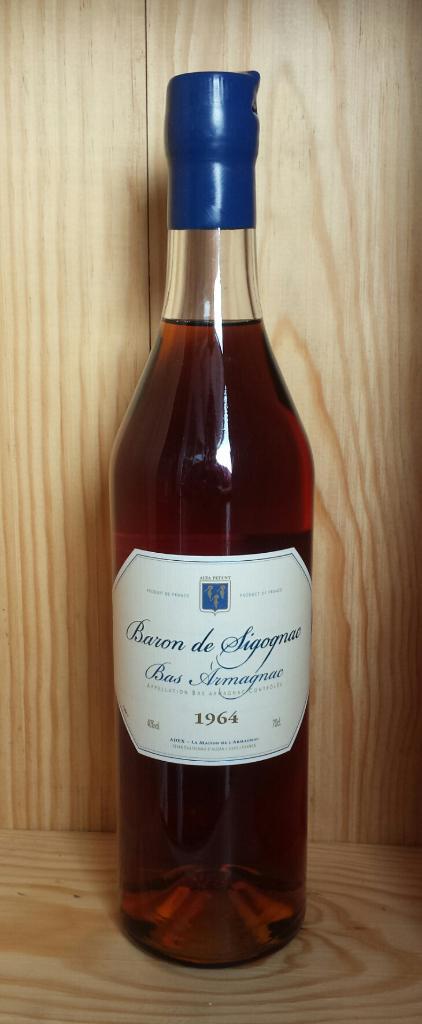How old is this bottle?
Offer a very short reply. 1964. What brand of wine is this?
Keep it short and to the point. Baron de sigognae. 